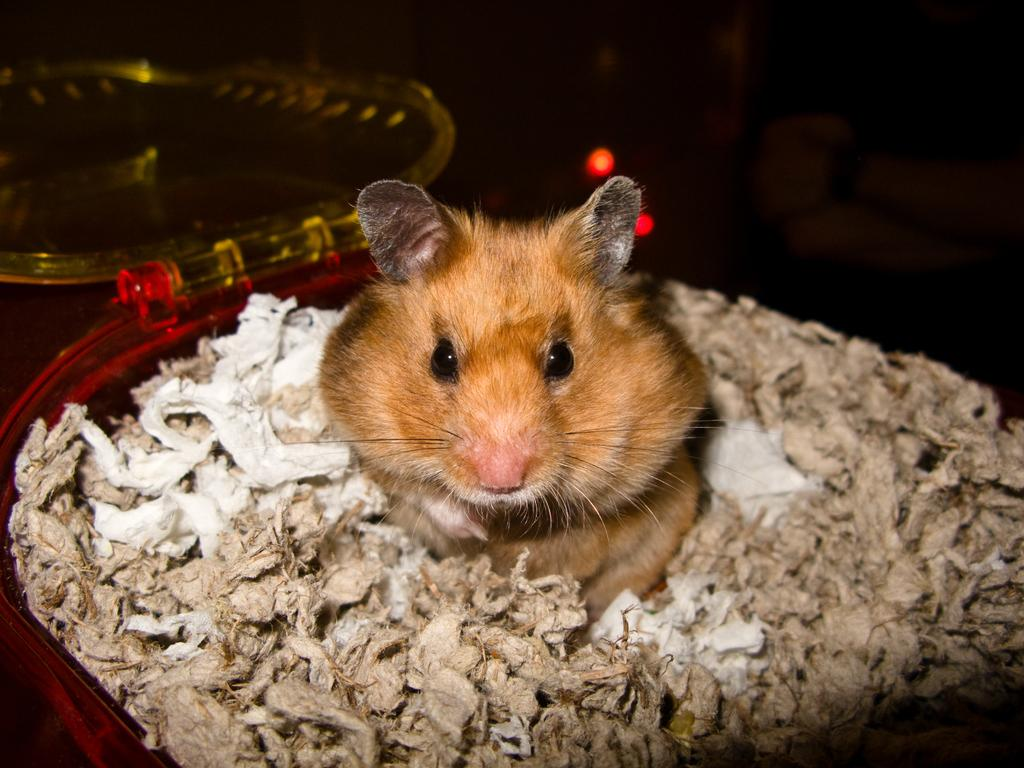What animal is present in the image? There is a rat in the image. How is the rat positioned in the image? The rat is placed in a basket. What type of vein can be seen in the image? There is no vein present in the image; it features a rat placed in a basket. What type of oatmeal is being served in the image? There is no oatmeal present in the image. 